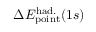<formula> <loc_0><loc_0><loc_500><loc_500>\Delta { E } _ { p o i n t } ^ { h a d . } ( 1 s )</formula> 